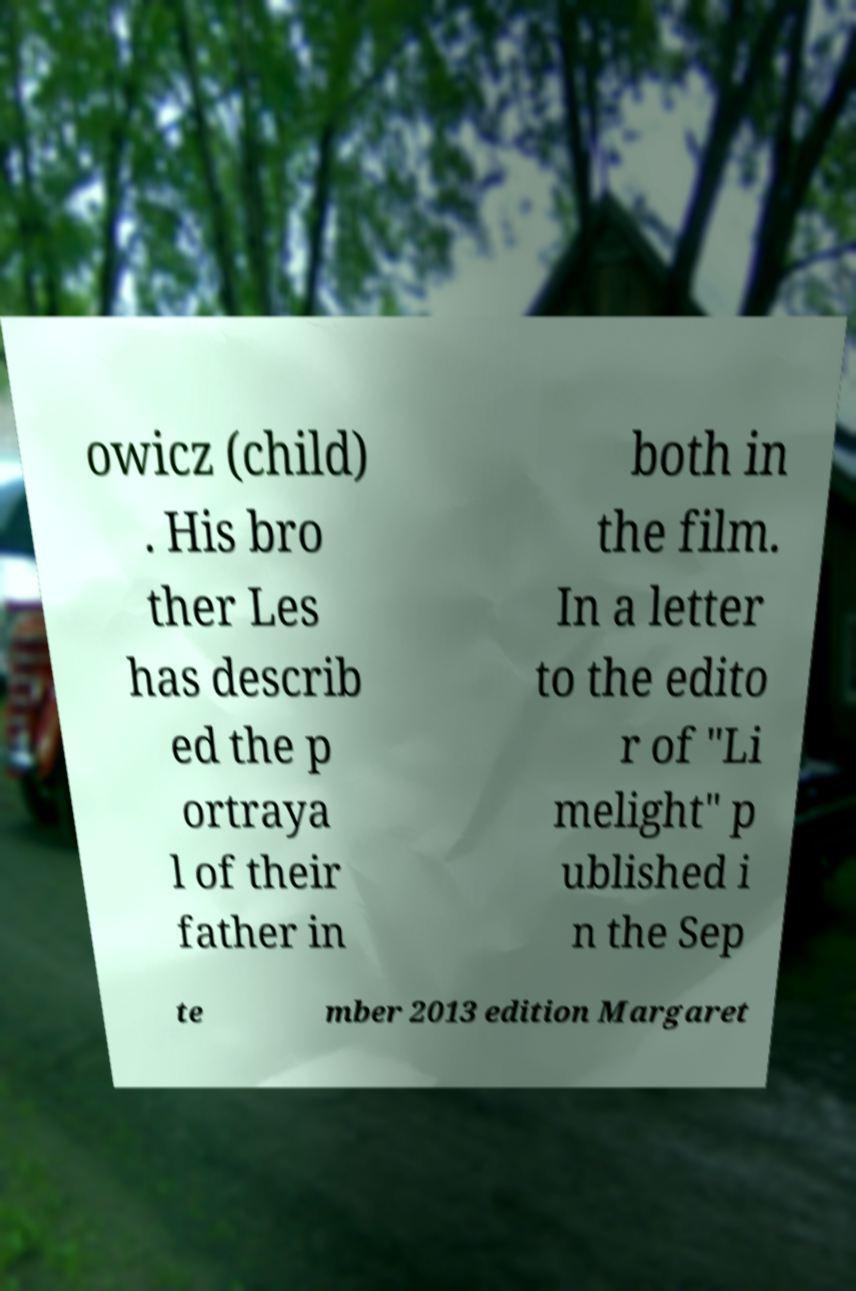For documentation purposes, I need the text within this image transcribed. Could you provide that? owicz (child) . His bro ther Les has describ ed the p ortraya l of their father in both in the film. In a letter to the edito r of "Li melight" p ublished i n the Sep te mber 2013 edition Margaret 